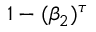<formula> <loc_0><loc_0><loc_500><loc_500>1 - ( \beta _ { 2 } ) ^ { \tau }</formula> 